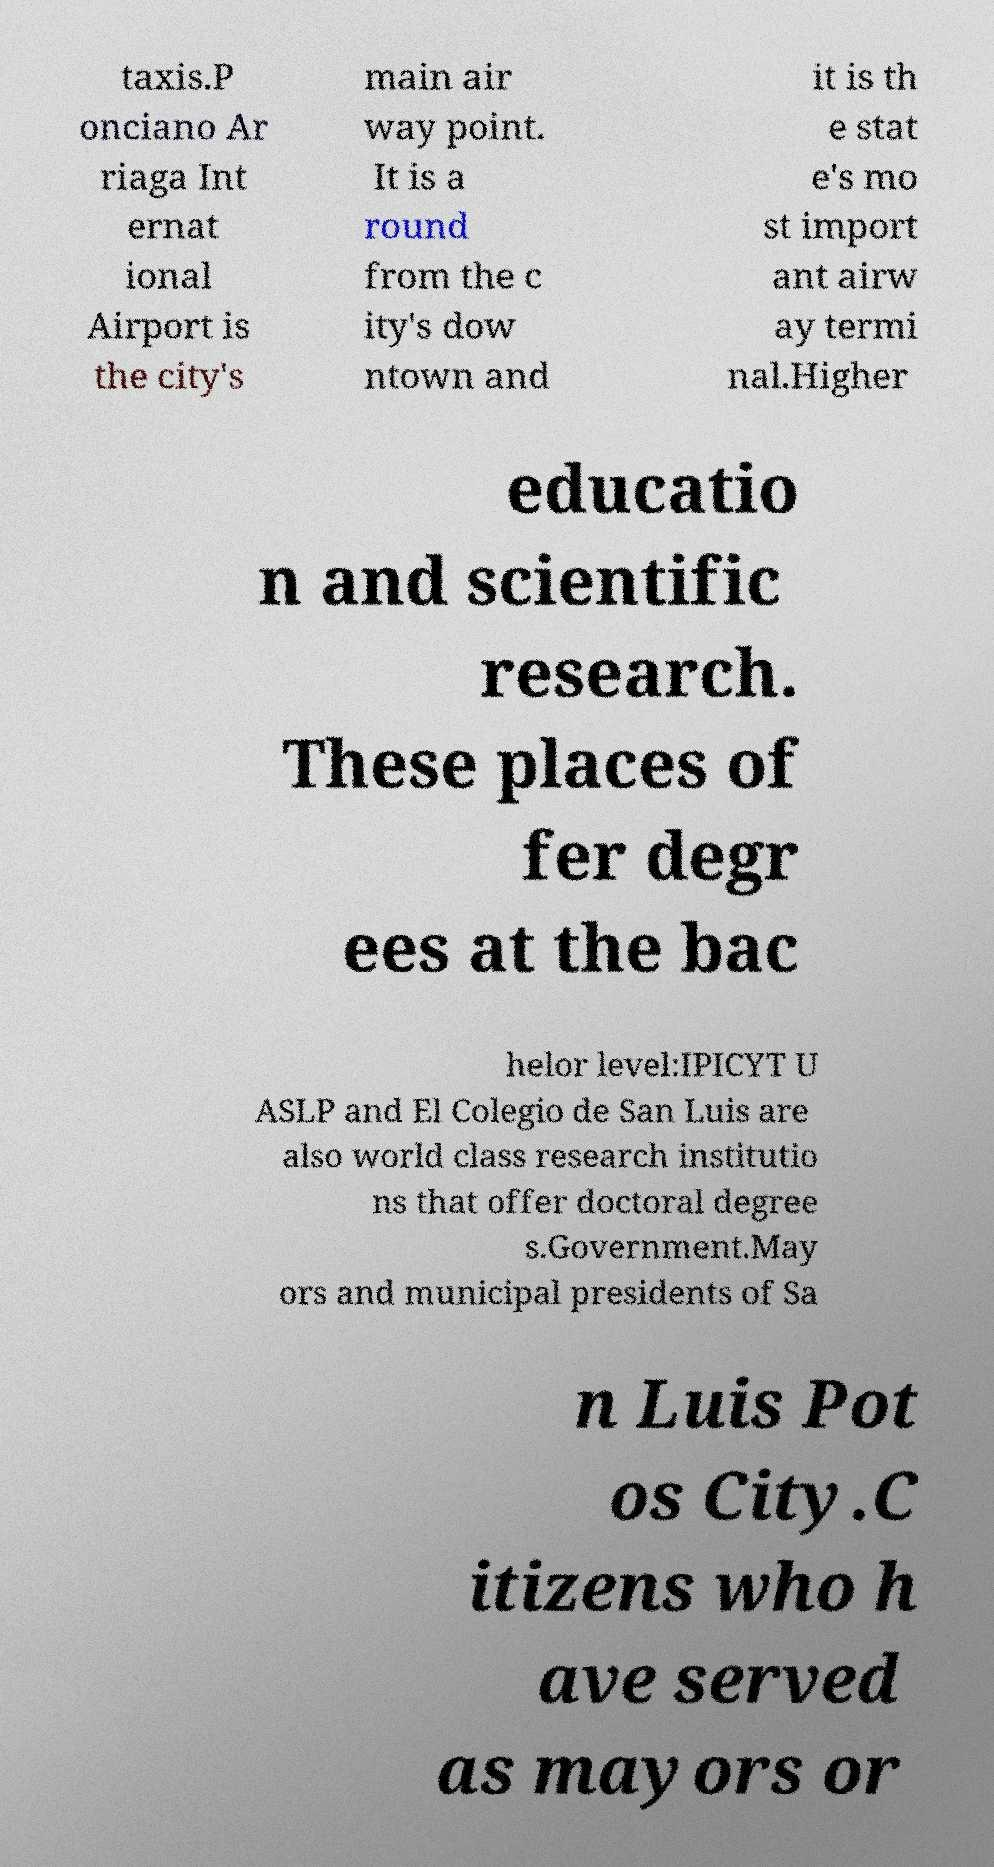There's text embedded in this image that I need extracted. Can you transcribe it verbatim? taxis.P onciano Ar riaga Int ernat ional Airport is the city's main air way point. It is a round from the c ity's dow ntown and it is th e stat e's mo st import ant airw ay termi nal.Higher educatio n and scientific research. These places of fer degr ees at the bac helor level:IPICYT U ASLP and El Colegio de San Luis are also world class research institutio ns that offer doctoral degree s.Government.May ors and municipal presidents of Sa n Luis Pot os City.C itizens who h ave served as mayors or 